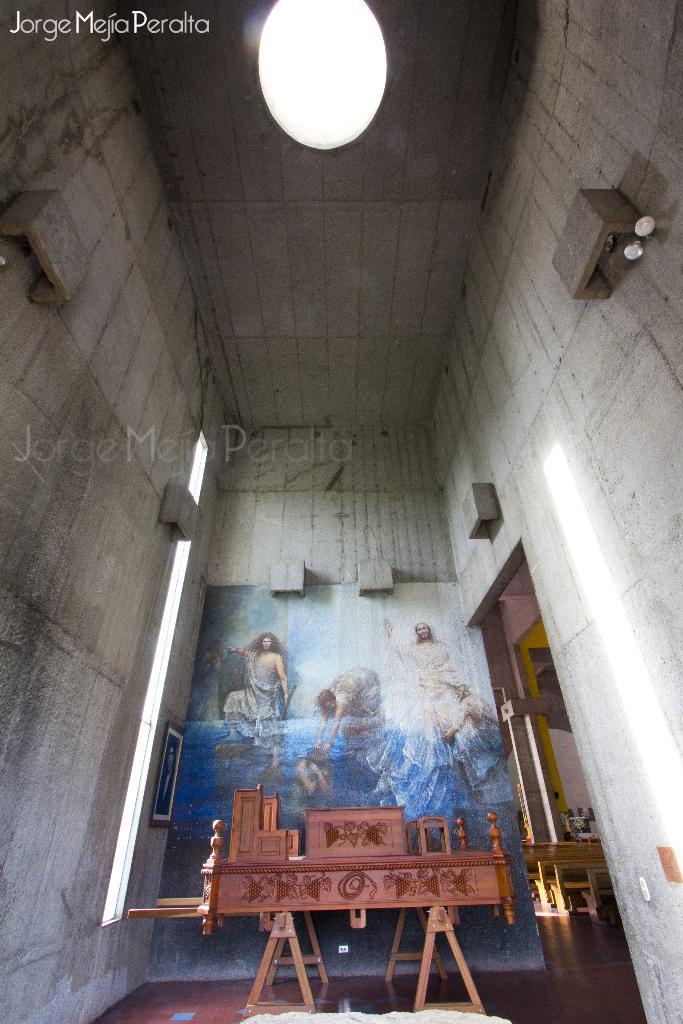Describe this image in one or two sentences. This is inside view of a building. There is a wooden table in the back. Also there is a painting on the wall. Also there is water mark on the image. 